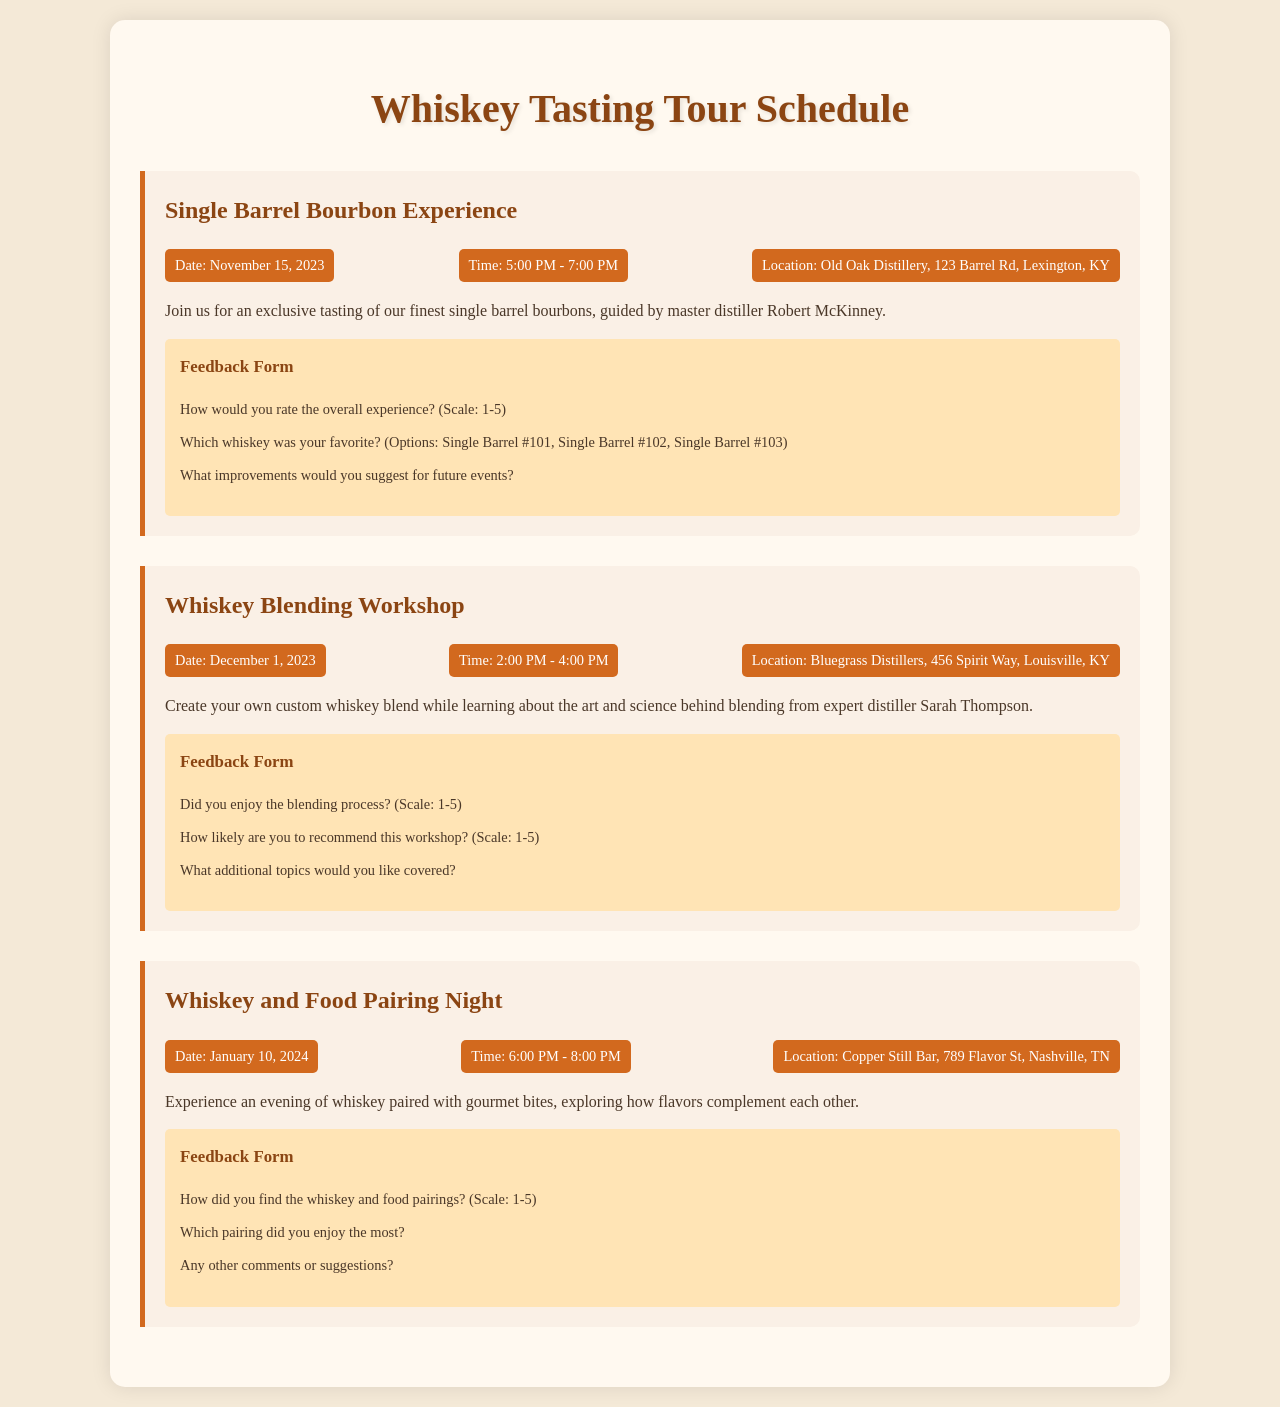What is the title of the first event? The title of the first event is found in the heading of the first event section, which is "Single Barrel Bourbon Experience".
Answer: Single Barrel Bourbon Experience What date is the Whiskey Blending Workshop scheduled for? The date of the Whiskey Blending Workshop is specified in the event details, which is December 1, 2023.
Answer: December 1, 2023 How long does the Whiskey and Food Pairing Night last? The duration of the Whiskey and Food Pairing Night can be determined by subtracting the start time from the end time, which is 2 hours.
Answer: 2 hours Who is the expert for the Whiskey Blending Workshop? The expert for the Whiskey Blending Workshop is mentioned in the event description as Sarah Thompson.
Answer: Sarah Thompson What feedback question is asked in the Single Barrel Bourbon Experience? The feedback form includes questions, one of which is "How would you rate the overall experience? (Scale: 1-5)".
Answer: How would you rate the overall experience? (Scale: 1-5) Which event's location is in Nashville, TN? The location can be found in the event details and matches the description for the "Whiskey and Food Pairing Night".
Answer: Copper Still Bar, 789 Flavor St, Nashville, TN 